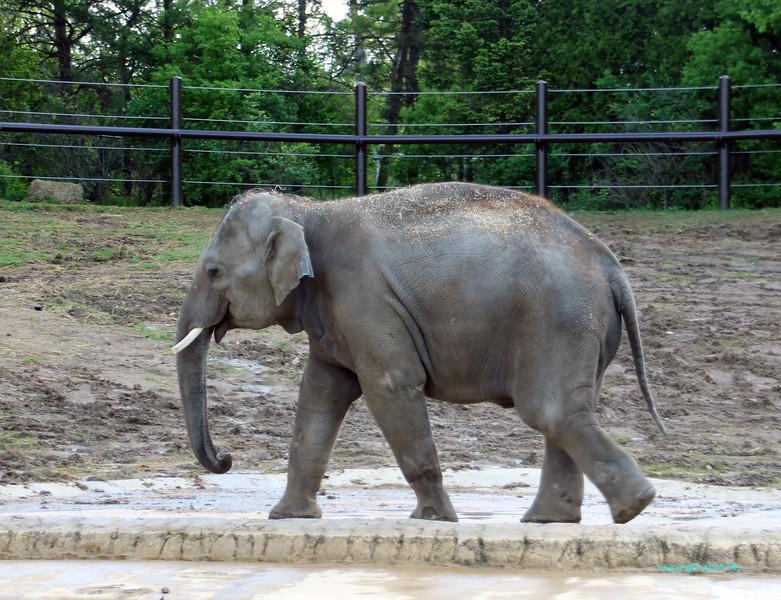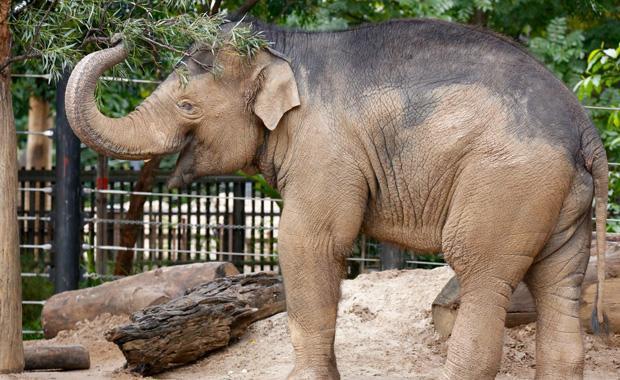The first image is the image on the left, the second image is the image on the right. For the images displayed, is the sentence "All elephants shown have tusks and exactly one elephant faces the camera." factually correct? Answer yes or no. No. The first image is the image on the left, the second image is the image on the right. Examine the images to the left and right. Is the description "The left image contains two elephants touching their heads to each others." accurate? Answer yes or no. No. 